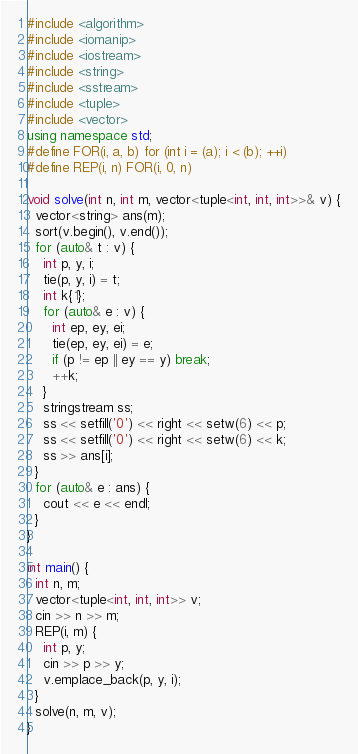Convert code to text. <code><loc_0><loc_0><loc_500><loc_500><_C++_>#include <algorithm>
#include <iomanip>
#include <iostream>
#include <string>
#include <sstream>
#include <tuple>
#include <vector>
using namespace std;
#define FOR(i, a, b) for (int i = (a); i < (b); ++i)
#define REP(i, n) FOR(i, 0, n)

void solve(int n, int m, vector<tuple<int, int, int>>& v) {
  vector<string> ans(m);
  sort(v.begin(), v.end());
  for (auto& t : v) {
    int p, y, i;
    tie(p, y, i) = t;
    int k{1};
    for (auto& e : v) {
      int ep, ey, ei;
      tie(ep, ey, ei) = e;
      if (p != ep || ey == y) break;
      ++k;
    }
    stringstream ss;
    ss << setfill('0') << right << setw(6) << p;
    ss << setfill('0') << right << setw(6) << k;
    ss >> ans[i];
  }
  for (auto& e : ans) {
    cout << e << endl;
  }
}

int main() {
  int n, m;
  vector<tuple<int, int, int>> v;
  cin >> n >> m;
  REP(i, m) {
    int p, y;
    cin >> p >> y;
    v.emplace_back(p, y, i);
  }
  solve(n, m, v);
}
</code> 